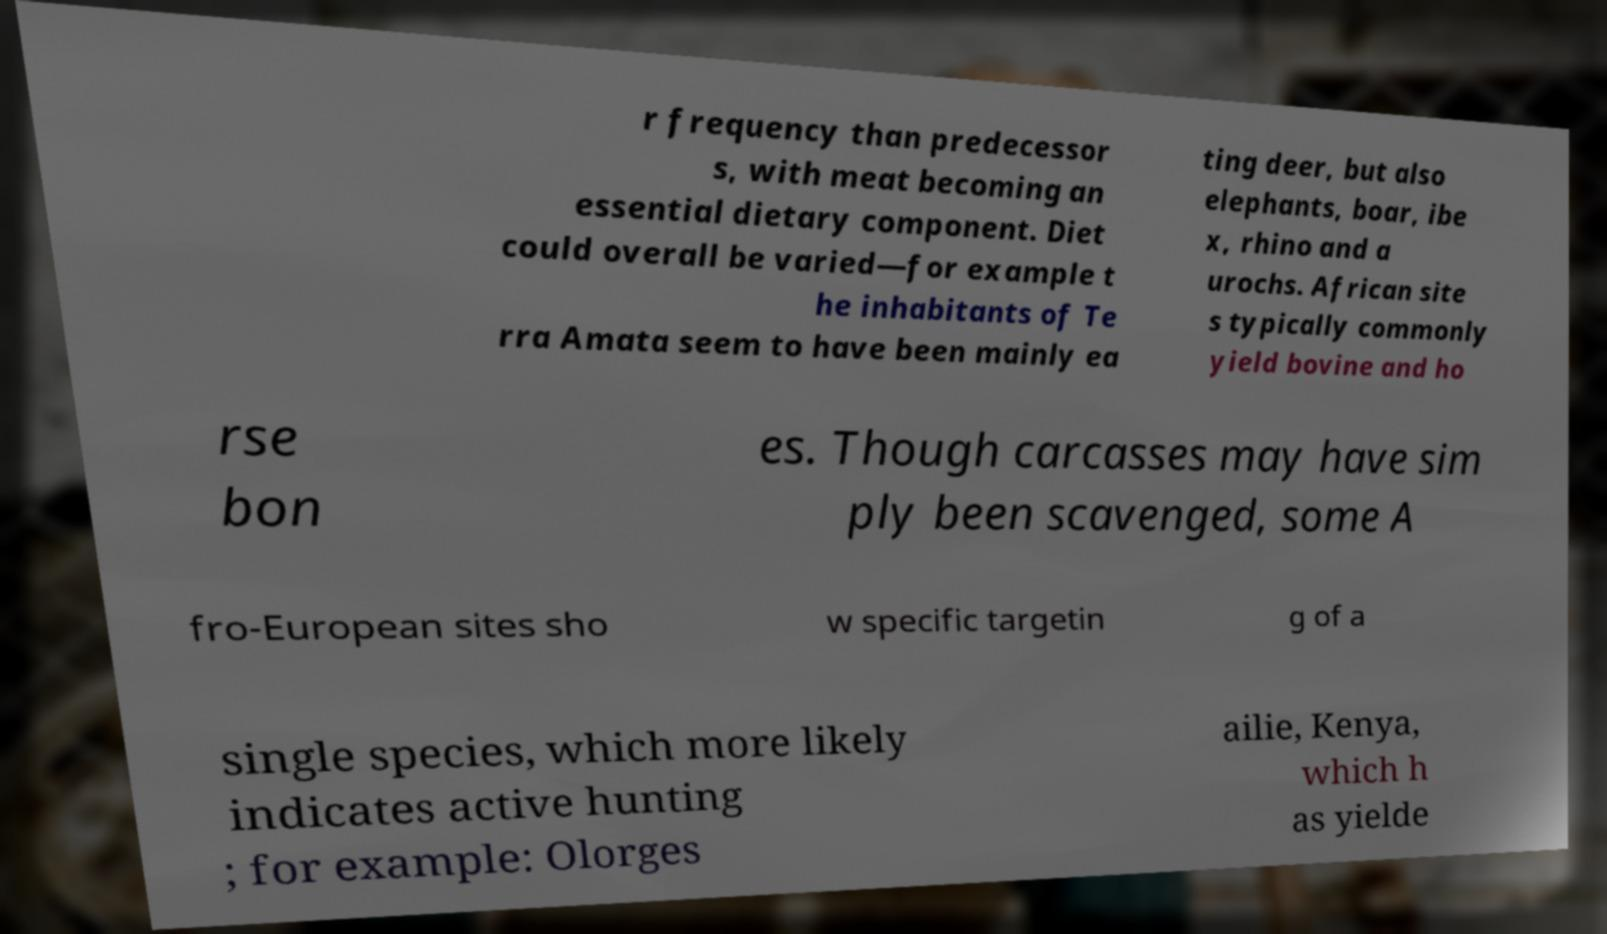Could you extract and type out the text from this image? r frequency than predecessor s, with meat becoming an essential dietary component. Diet could overall be varied—for example t he inhabitants of Te rra Amata seem to have been mainly ea ting deer, but also elephants, boar, ibe x, rhino and a urochs. African site s typically commonly yield bovine and ho rse bon es. Though carcasses may have sim ply been scavenged, some A fro-European sites sho w specific targetin g of a single species, which more likely indicates active hunting ; for example: Olorges ailie, Kenya, which h as yielde 